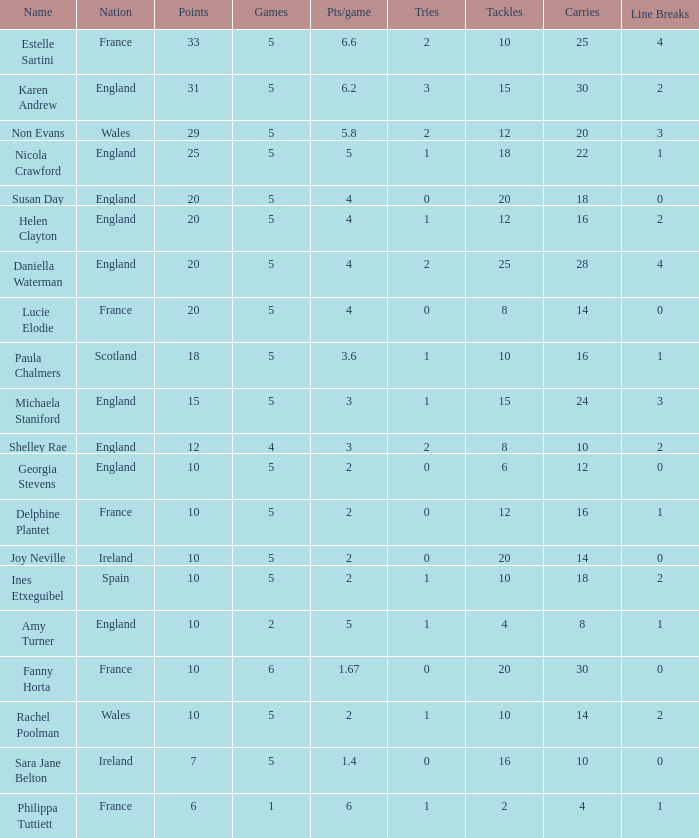Can you tell me the lowest Games that has the Pts/game larger than 1.4 and the Points of 20, and the Name of susan day? 5.0. 